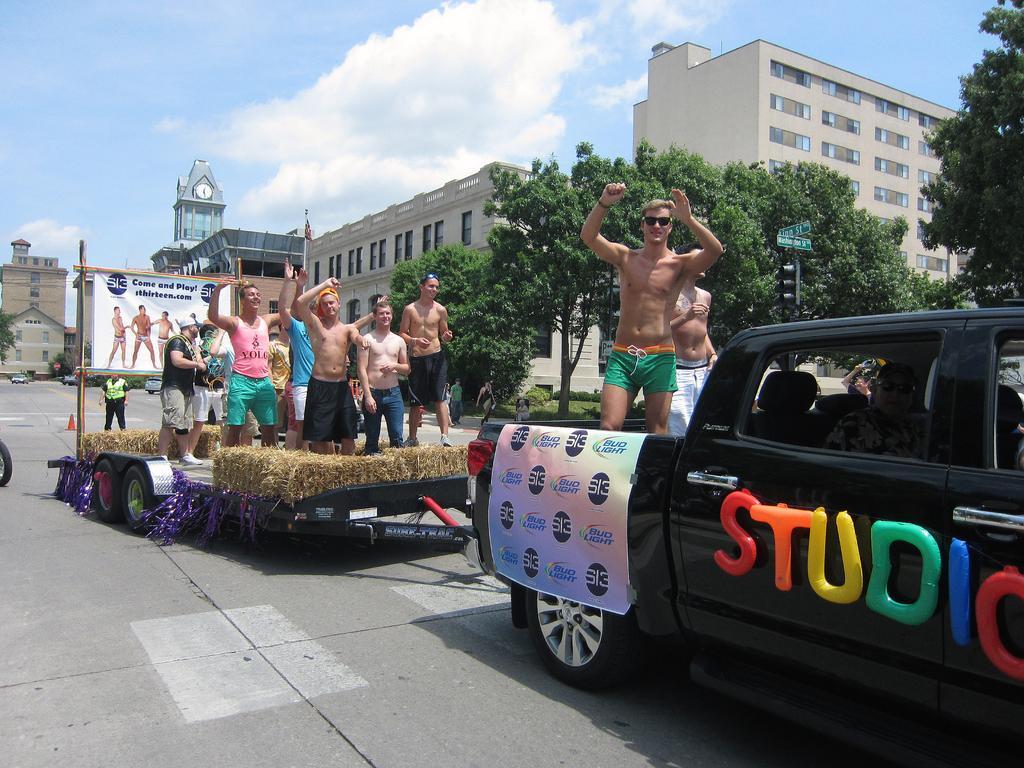Could you give a brief overview of what you see in this image? As we can see in the image there is a sky, trees, buildings, a clock, banner and few people standing over here and a truck. 